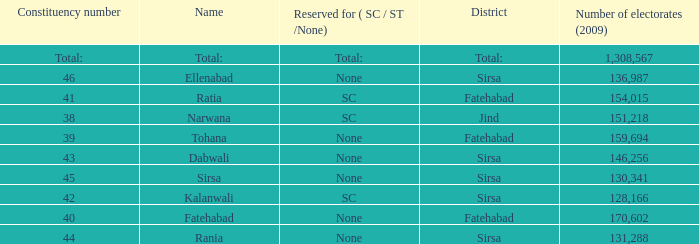Which Number of electorates (2009) has a Constituency number of 46? 136987.0. 